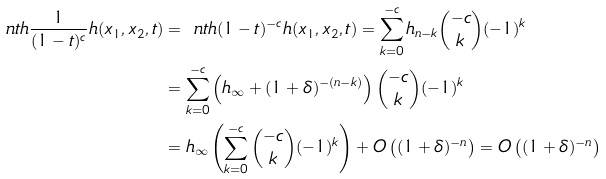Convert formula to latex. <formula><loc_0><loc_0><loc_500><loc_500>\ n t h { \frac { 1 } { ( 1 - t ) ^ { c } } h ( x _ { 1 } , x _ { 2 } , t ) } & = \ n t h { ( 1 - t ) ^ { - c } h ( x _ { 1 } , x _ { 2 } , t ) } = \sum _ { k = 0 } ^ { - c } h _ { n - k } \binom { - c } { k } ( - 1 ) ^ { k } \\ & = \sum _ { k = 0 } ^ { - c } \left ( h _ { \infty } + ( 1 + \delta ) ^ { - ( n - k ) } \right ) \binom { - c } { k } ( - 1 ) ^ { k } \\ & = h _ { \infty } \left ( \sum _ { k = 0 } ^ { - c } \binom { - c } { k } ( - 1 ) ^ { k } \right ) + O \left ( ( 1 + \delta ) ^ { - n } \right ) = O \left ( ( 1 + \delta ) ^ { - n } \right )</formula> 